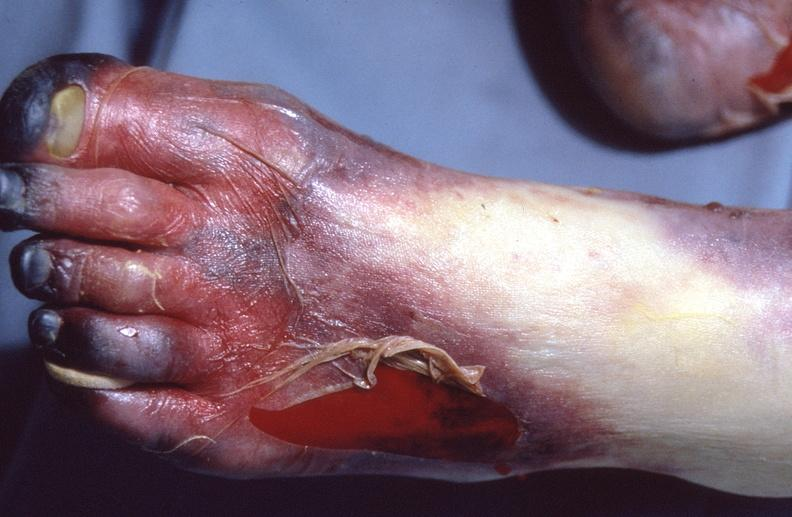does child show skin ulceration and necrosis, disseminated intravascular coagulation due to acetaminophen toxicity?
Answer the question using a single word or phrase. No 